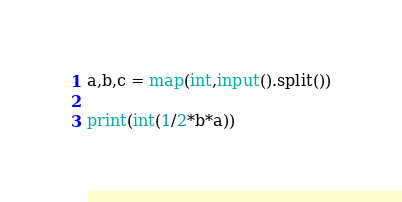Convert code to text. <code><loc_0><loc_0><loc_500><loc_500><_Python_>a,b,c = map(int,input().split())

print(int(1/2*b*a))</code> 